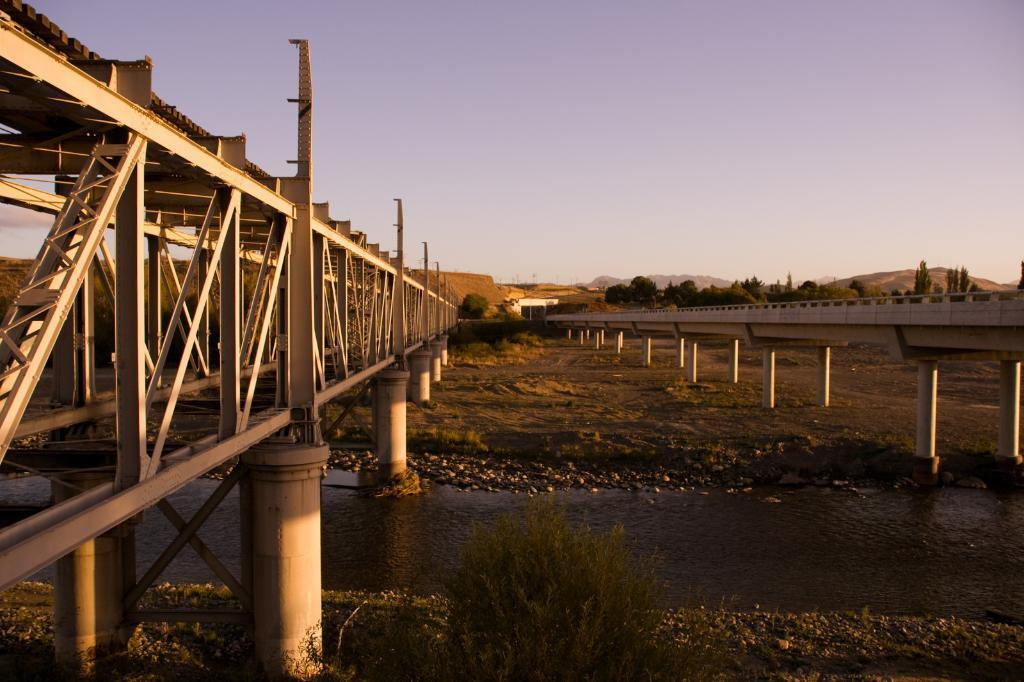What type of structures can be seen in the image? There are bridges in the image. What natural element is visible in the image? There is water visible in the image. What type of terrain can be seen in the image? There are rocks, trees, and hills in the image. What is visible in the background of the image? The sky is visible in the background of the image. What type of competition is taking place in the image? There is no competition present in the image. Can you describe the experience of the rocks in the image? The rocks in the image are stationary and cannot have an experience. 